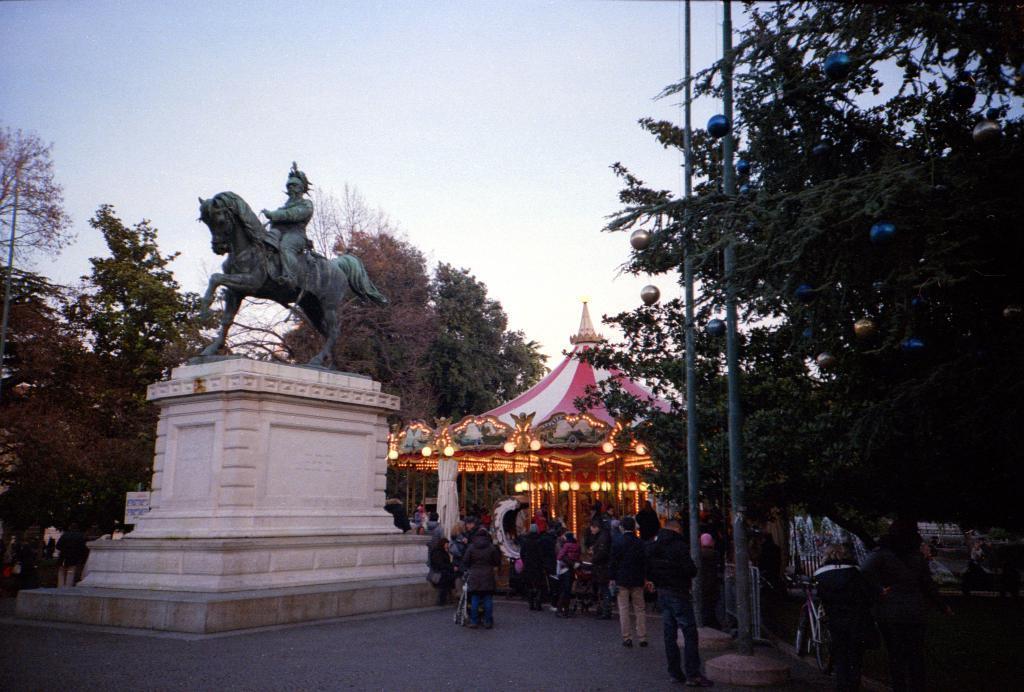Describe this image in one or two sentences. In this image there is the sky, there are trees truncated towards the right of the image, there are trees truncated towards the left of the image, there is a sculptor, there are lights, there are persons, there are poles truncated towards the top of the image, there is a bicycle, there is person truncated towards the bottom of the image, there is the road, there is text on the wall. 